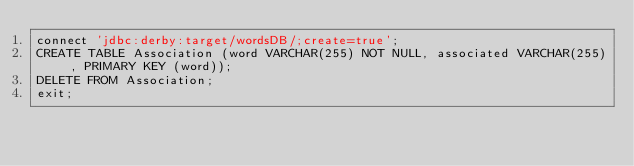Convert code to text. <code><loc_0><loc_0><loc_500><loc_500><_SQL_>connect 'jdbc:derby:target/wordsDB/;create=true';
CREATE TABLE Association (word VARCHAR(255) NOT NULL, associated VARCHAR(255), PRIMARY KEY (word));
DELETE FROM Association;
exit;
</code> 